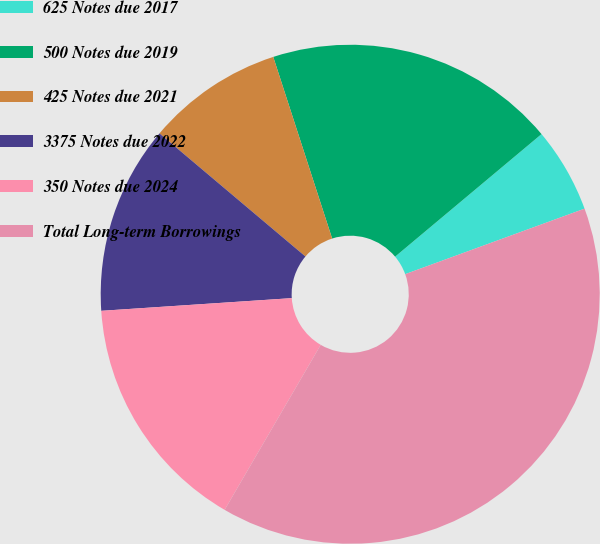Convert chart to OTSL. <chart><loc_0><loc_0><loc_500><loc_500><pie_chart><fcel>625 Notes due 2017<fcel>500 Notes due 2019<fcel>425 Notes due 2021<fcel>3375 Notes due 2022<fcel>350 Notes due 2024<fcel>Total Long-term Borrowings<nl><fcel>5.52%<fcel>18.9%<fcel>8.86%<fcel>12.21%<fcel>15.55%<fcel>38.97%<nl></chart> 